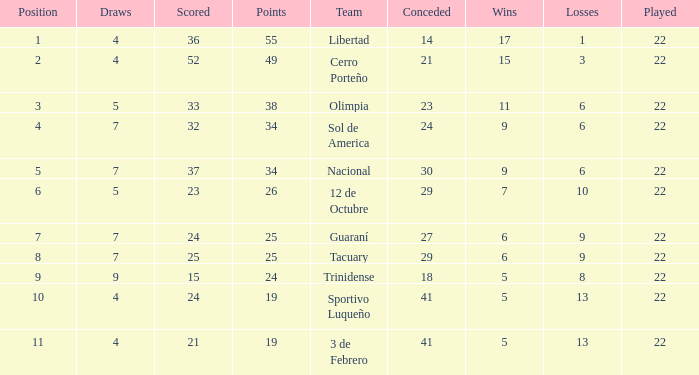Can you parse all the data within this table? {'header': ['Position', 'Draws', 'Scored', 'Points', 'Team', 'Conceded', 'Wins', 'Losses', 'Played'], 'rows': [['1', '4', '36', '55', 'Libertad', '14', '17', '1', '22'], ['2', '4', '52', '49', 'Cerro Porteño', '21', '15', '3', '22'], ['3', '5', '33', '38', 'Olimpia', '23', '11', '6', '22'], ['4', '7', '32', '34', 'Sol de America', '24', '9', '6', '22'], ['5', '7', '37', '34', 'Nacional', '30', '9', '6', '22'], ['6', '5', '23', '26', '12 de Octubre', '29', '7', '10', '22'], ['7', '7', '24', '25', 'Guaraní', '27', '6', '9', '22'], ['8', '7', '25', '25', 'Tacuary', '29', '6', '9', '22'], ['9', '9', '15', '24', 'Trinidense', '18', '5', '8', '22'], ['10', '4', '24', '19', 'Sportivo Luqueño', '41', '5', '13', '22'], ['11', '4', '21', '19', '3 de Febrero', '41', '5', '13', '22']]} What was the number of losses when the scored value was 25? 9.0. 